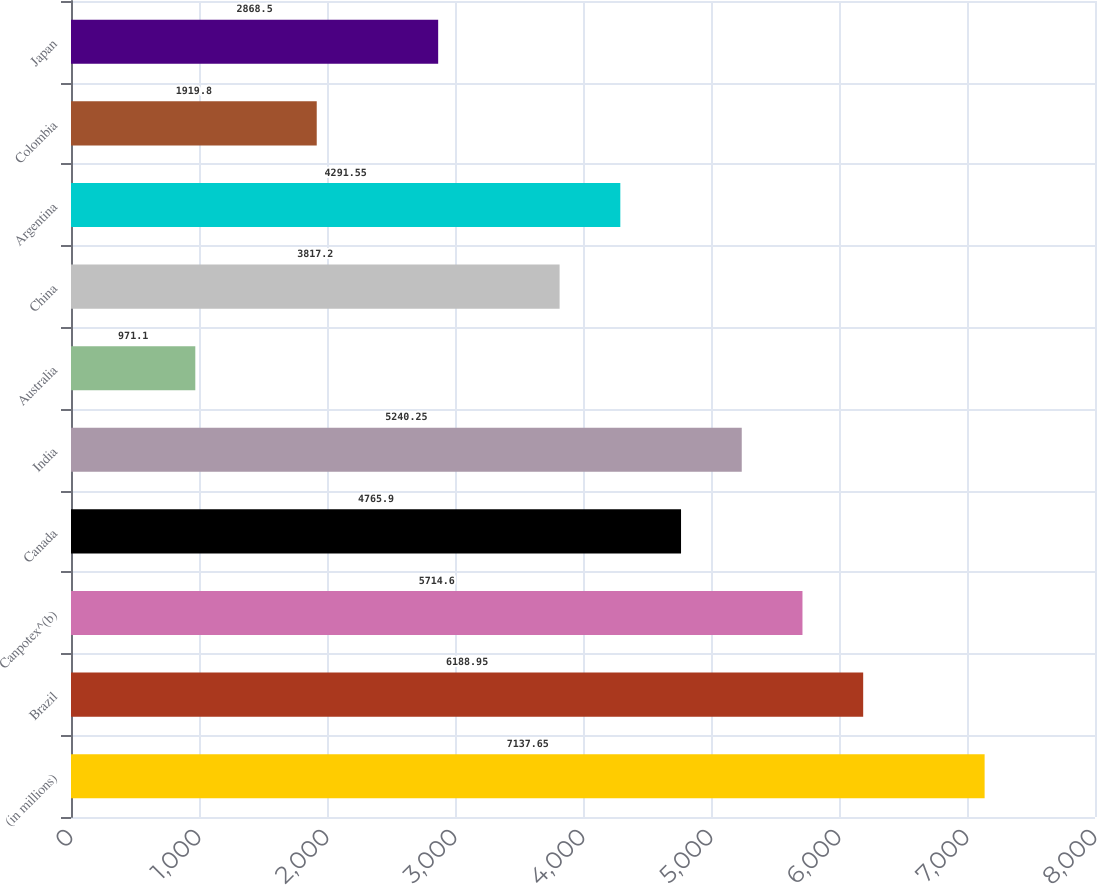Convert chart. <chart><loc_0><loc_0><loc_500><loc_500><bar_chart><fcel>(in millions)<fcel>Brazil<fcel>Canpotex^(b)<fcel>Canada<fcel>India<fcel>Australia<fcel>China<fcel>Argentina<fcel>Colombia<fcel>Japan<nl><fcel>7137.65<fcel>6188.95<fcel>5714.6<fcel>4765.9<fcel>5240.25<fcel>971.1<fcel>3817.2<fcel>4291.55<fcel>1919.8<fcel>2868.5<nl></chart> 